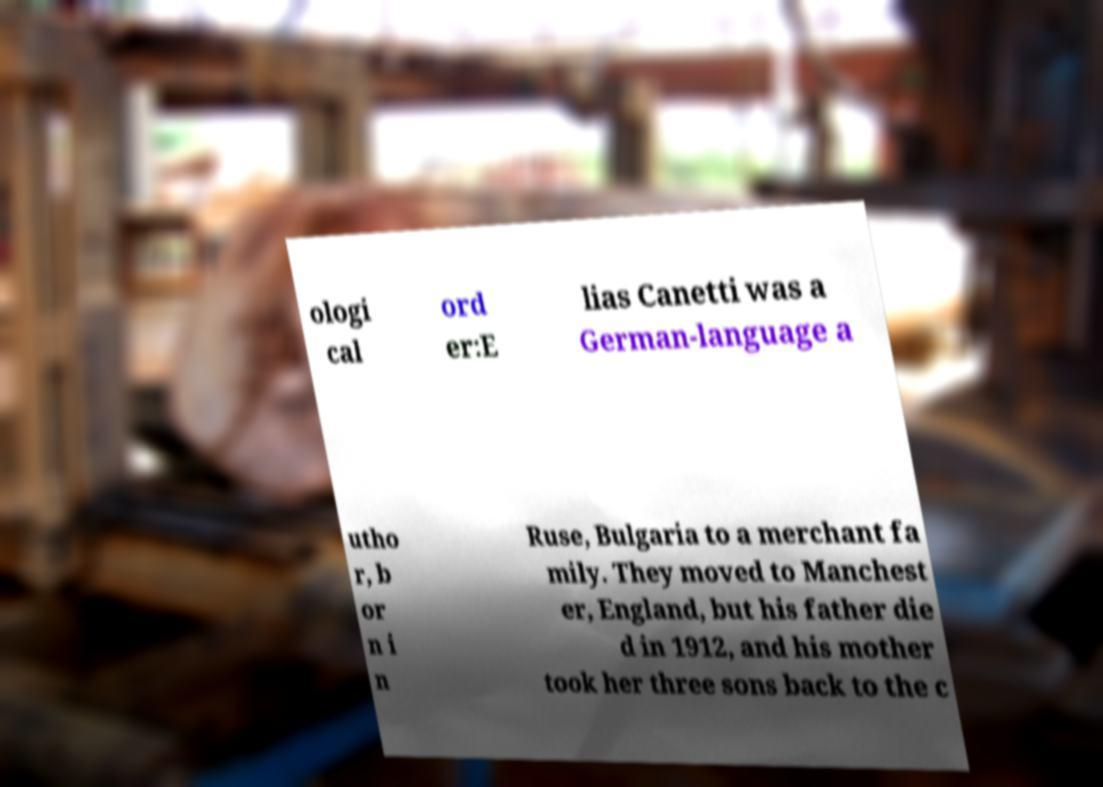Can you read and provide the text displayed in the image?This photo seems to have some interesting text. Can you extract and type it out for me? ologi cal ord er:E lias Canetti was a German-language a utho r, b or n i n Ruse, Bulgaria to a merchant fa mily. They moved to Manchest er, England, but his father die d in 1912, and his mother took her three sons back to the c 